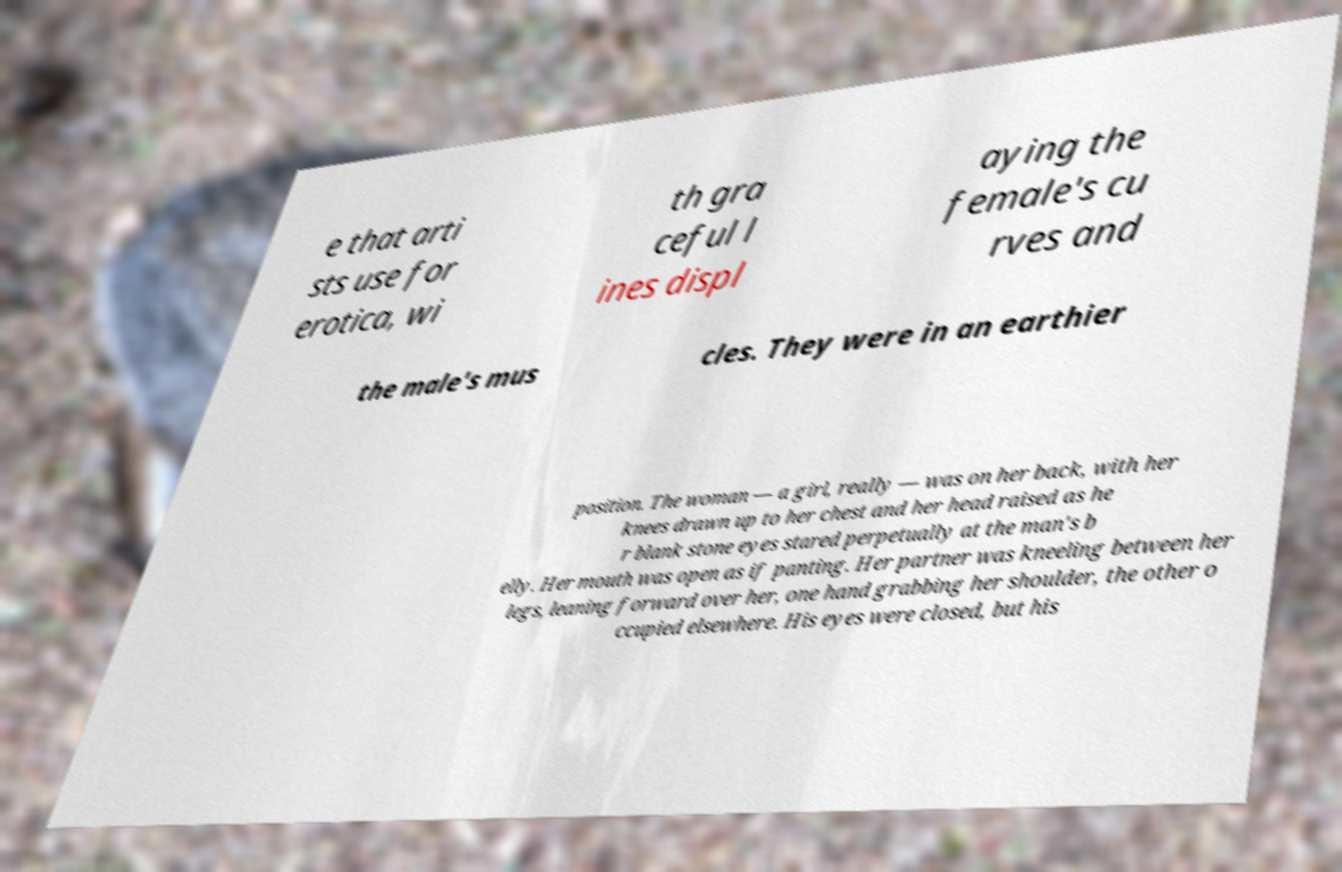Please identify and transcribe the text found in this image. e that arti sts use for erotica, wi th gra ceful l ines displ aying the female's cu rves and the male's mus cles. They were in an earthier position. The woman — a girl, really — was on her back, with her knees drawn up to her chest and her head raised as he r blank stone eyes stared perpetually at the man's b elly. Her mouth was open as if panting. Her partner was kneeling between her legs, leaning forward over her, one hand grabbing her shoulder, the other o ccupied elsewhere. His eyes were closed, but his 